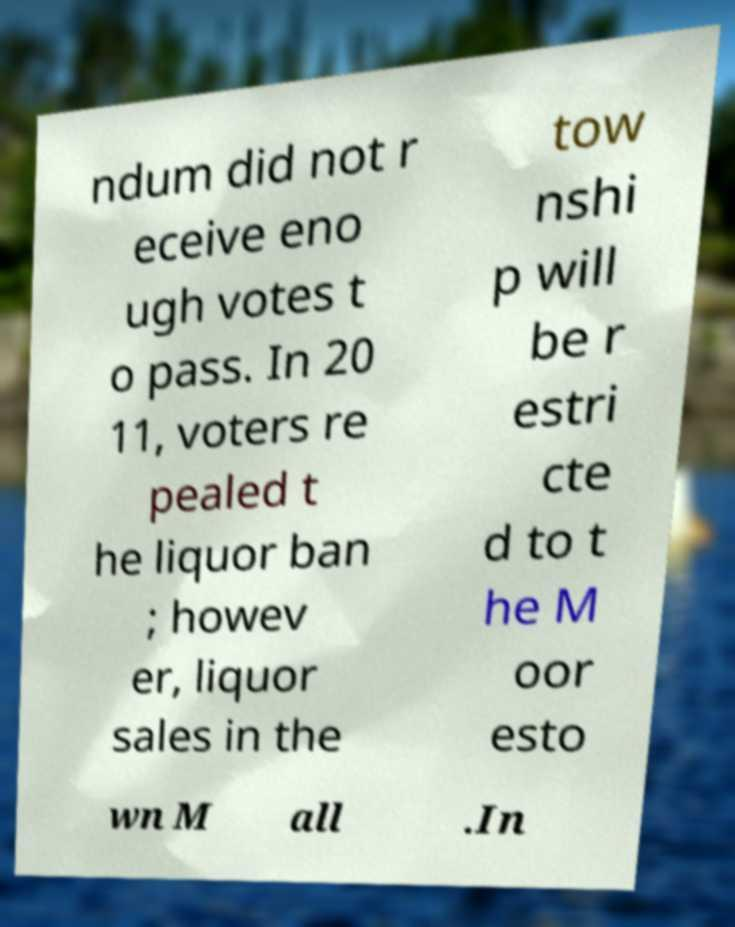For documentation purposes, I need the text within this image transcribed. Could you provide that? ndum did not r eceive eno ugh votes t o pass. In 20 11, voters re pealed t he liquor ban ; howev er, liquor sales in the tow nshi p will be r estri cte d to t he M oor esto wn M all .In 